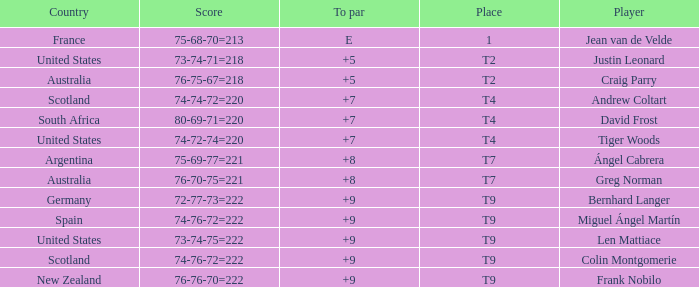Which player from the United States is in a place of T2? Justin Leonard. 